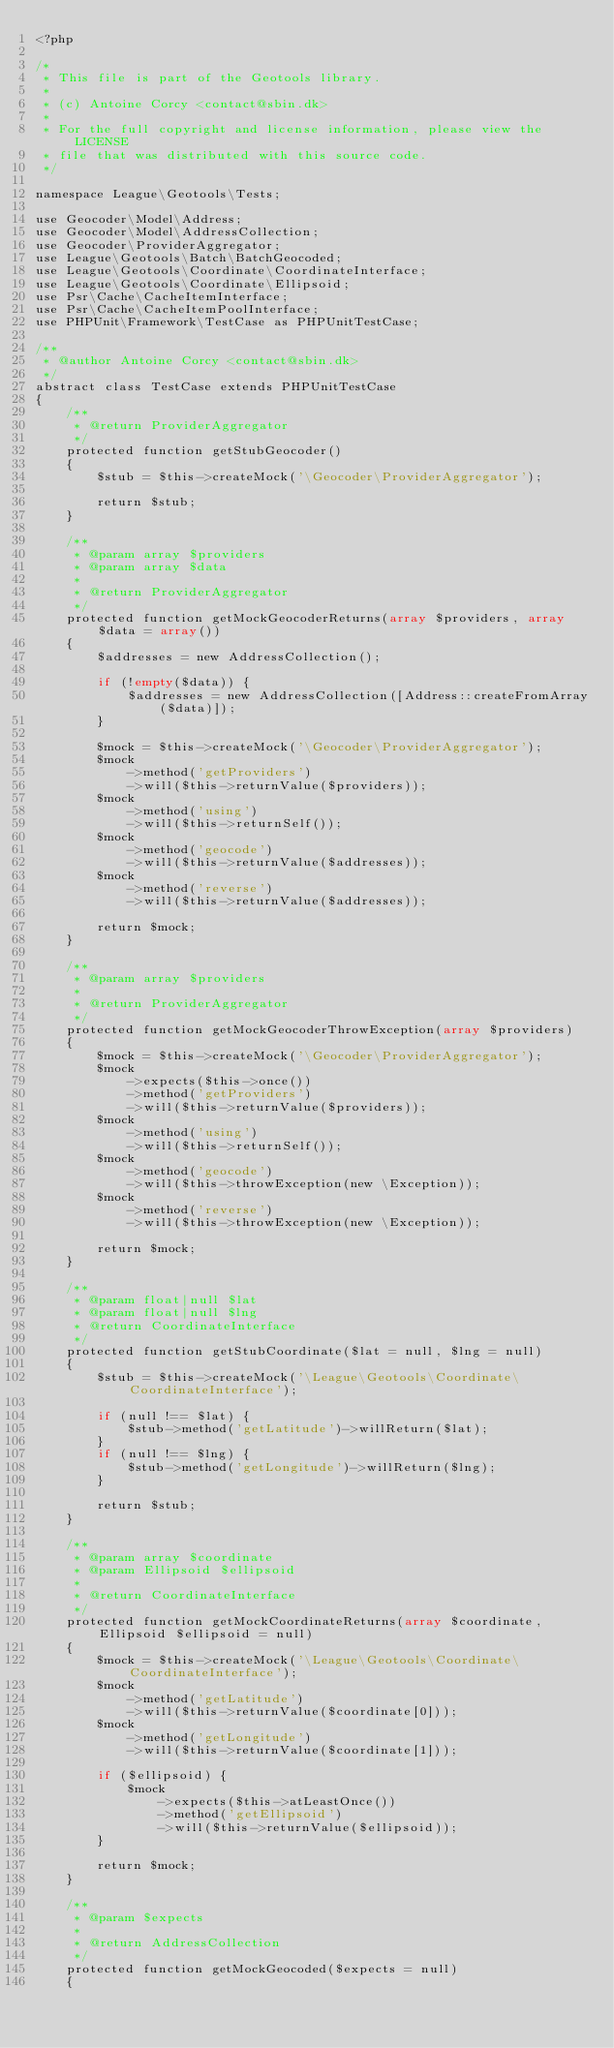Convert code to text. <code><loc_0><loc_0><loc_500><loc_500><_PHP_><?php

/*
 * This file is part of the Geotools library.
 *
 * (c) Antoine Corcy <contact@sbin.dk>
 *
 * For the full copyright and license information, please view the LICENSE
 * file that was distributed with this source code.
 */

namespace League\Geotools\Tests;

use Geocoder\Model\Address;
use Geocoder\Model\AddressCollection;
use Geocoder\ProviderAggregator;
use League\Geotools\Batch\BatchGeocoded;
use League\Geotools\Coordinate\CoordinateInterface;
use League\Geotools\Coordinate\Ellipsoid;
use Psr\Cache\CacheItemInterface;
use Psr\Cache\CacheItemPoolInterface;
use PHPUnit\Framework\TestCase as PHPUnitTestCase;

/**
 * @author Antoine Corcy <contact@sbin.dk>
 */
abstract class TestCase extends PHPUnitTestCase
{
    /**
     * @return ProviderAggregator
     */
    protected function getStubGeocoder()
    {
        $stub = $this->createMock('\Geocoder\ProviderAggregator');

        return $stub;
    }

    /**
     * @param array $providers
     * @param array $data
     *
     * @return ProviderAggregator
     */
    protected function getMockGeocoderReturns(array $providers, array $data = array())
    {
        $addresses = new AddressCollection();

        if (!empty($data)) {
            $addresses = new AddressCollection([Address::createFromArray($data)]);
        }

        $mock = $this->createMock('\Geocoder\ProviderAggregator');
        $mock
            ->method('getProviders')
            ->will($this->returnValue($providers));
        $mock
            ->method('using')
            ->will($this->returnSelf());
        $mock
            ->method('geocode')
            ->will($this->returnValue($addresses));
        $mock
            ->method('reverse')
            ->will($this->returnValue($addresses));

        return $mock;
    }

    /**
     * @param array $providers
     *
     * @return ProviderAggregator
     */
    protected function getMockGeocoderThrowException(array $providers)
    {
        $mock = $this->createMock('\Geocoder\ProviderAggregator');
        $mock
            ->expects($this->once())
            ->method('getProviders')
            ->will($this->returnValue($providers));
        $mock
            ->method('using')
            ->will($this->returnSelf());
        $mock
            ->method('geocode')
            ->will($this->throwException(new \Exception));
        $mock
            ->method('reverse')
            ->will($this->throwException(new \Exception));

        return $mock;
    }

    /**
     * @param float|null $lat
     * @param float|null $lng
     * @return CoordinateInterface
     */
    protected function getStubCoordinate($lat = null, $lng = null)
    {
        $stub = $this->createMock('\League\Geotools\Coordinate\CoordinateInterface');

        if (null !== $lat) {
            $stub->method('getLatitude')->willReturn($lat);
        }
        if (null !== $lng) {
            $stub->method('getLongitude')->willReturn($lng);
        }

        return $stub;
    }

    /**
     * @param array $coordinate
     * @param Ellipsoid $ellipsoid
     *
     * @return CoordinateInterface
     */
    protected function getMockCoordinateReturns(array $coordinate, Ellipsoid $ellipsoid = null)
    {
        $mock = $this->createMock('\League\Geotools\Coordinate\CoordinateInterface');
        $mock
            ->method('getLatitude')
            ->will($this->returnValue($coordinate[0]));
        $mock
            ->method('getLongitude')
            ->will($this->returnValue($coordinate[1]));

        if ($ellipsoid) {
            $mock
                ->expects($this->atLeastOnce())
                ->method('getEllipsoid')
                ->will($this->returnValue($ellipsoid));
        }

        return $mock;
    }

    /**
     * @param $expects
     *
     * @return AddressCollection
     */
    protected function getMockGeocoded($expects = null)
    {</code> 